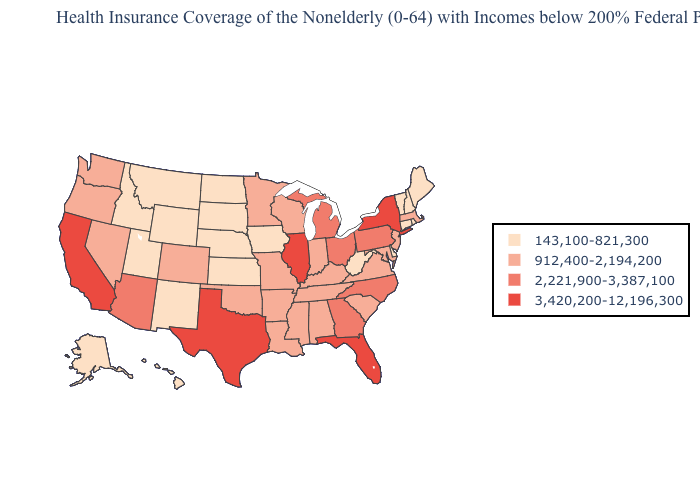What is the lowest value in the USA?
Keep it brief. 143,100-821,300. What is the highest value in the USA?
Quick response, please. 3,420,200-12,196,300. What is the value of Nevada?
Short answer required. 912,400-2,194,200. Name the states that have a value in the range 3,420,200-12,196,300?
Short answer required. California, Florida, Illinois, New York, Texas. Name the states that have a value in the range 143,100-821,300?
Give a very brief answer. Alaska, Connecticut, Delaware, Hawaii, Idaho, Iowa, Kansas, Maine, Montana, Nebraska, New Hampshire, New Mexico, North Dakota, Rhode Island, South Dakota, Utah, Vermont, West Virginia, Wyoming. What is the value of New Mexico?
Write a very short answer. 143,100-821,300. Name the states that have a value in the range 3,420,200-12,196,300?
Be succinct. California, Florida, Illinois, New York, Texas. What is the value of Connecticut?
Concise answer only. 143,100-821,300. Which states hav the highest value in the MidWest?
Quick response, please. Illinois. Does Florida have the lowest value in the South?
Concise answer only. No. Name the states that have a value in the range 143,100-821,300?
Write a very short answer. Alaska, Connecticut, Delaware, Hawaii, Idaho, Iowa, Kansas, Maine, Montana, Nebraska, New Hampshire, New Mexico, North Dakota, Rhode Island, South Dakota, Utah, Vermont, West Virginia, Wyoming. Name the states that have a value in the range 912,400-2,194,200?
Quick response, please. Alabama, Arkansas, Colorado, Indiana, Kentucky, Louisiana, Maryland, Massachusetts, Minnesota, Mississippi, Missouri, Nevada, New Jersey, Oklahoma, Oregon, South Carolina, Tennessee, Virginia, Washington, Wisconsin. Among the states that border Oregon , which have the lowest value?
Short answer required. Idaho. Which states have the highest value in the USA?
Be succinct. California, Florida, Illinois, New York, Texas. Which states have the lowest value in the USA?
Write a very short answer. Alaska, Connecticut, Delaware, Hawaii, Idaho, Iowa, Kansas, Maine, Montana, Nebraska, New Hampshire, New Mexico, North Dakota, Rhode Island, South Dakota, Utah, Vermont, West Virginia, Wyoming. 